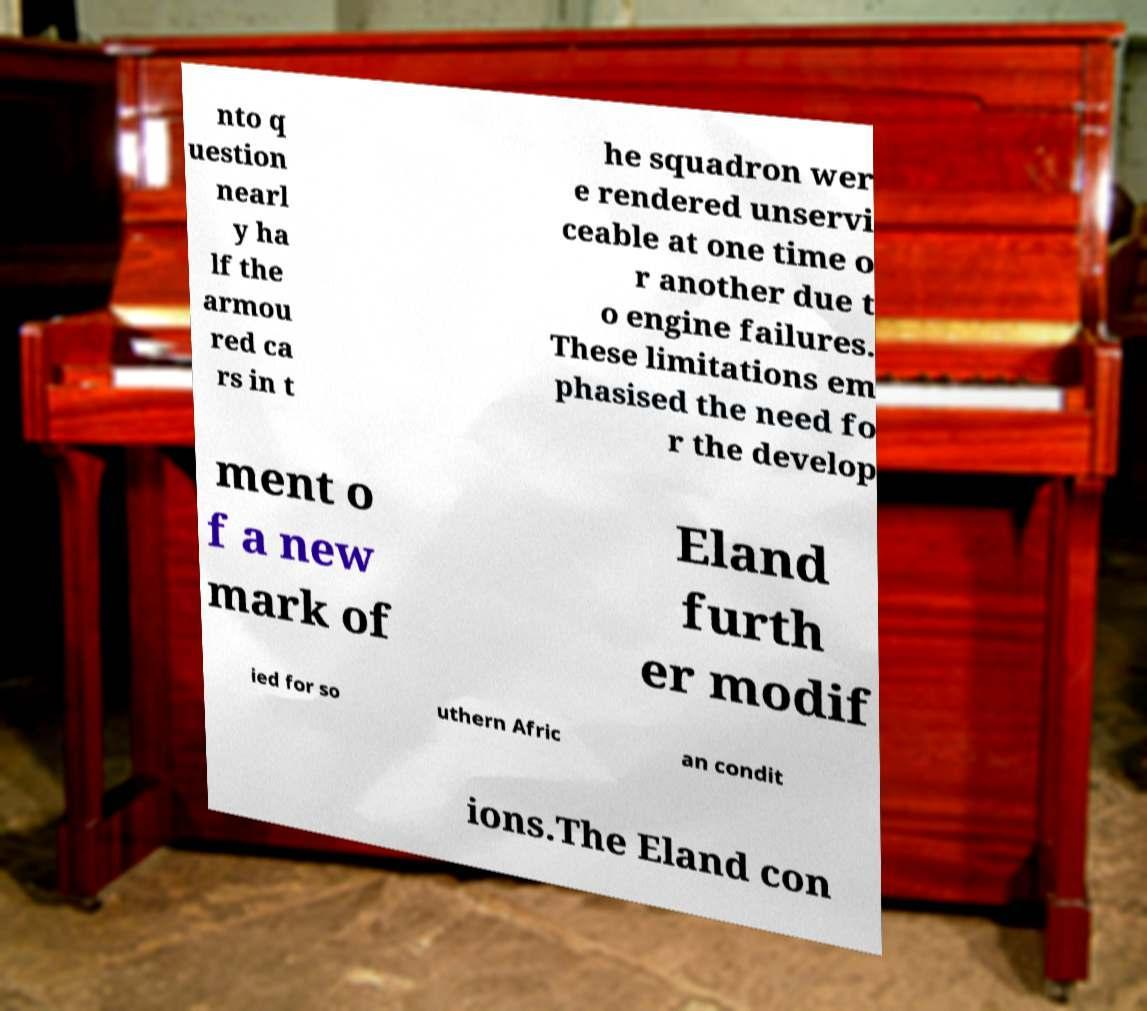Please read and relay the text visible in this image. What does it say? nto q uestion nearl y ha lf the armou red ca rs in t he squadron wer e rendered unservi ceable at one time o r another due t o engine failures. These limitations em phasised the need fo r the develop ment o f a new mark of Eland furth er modif ied for so uthern Afric an condit ions.The Eland con 